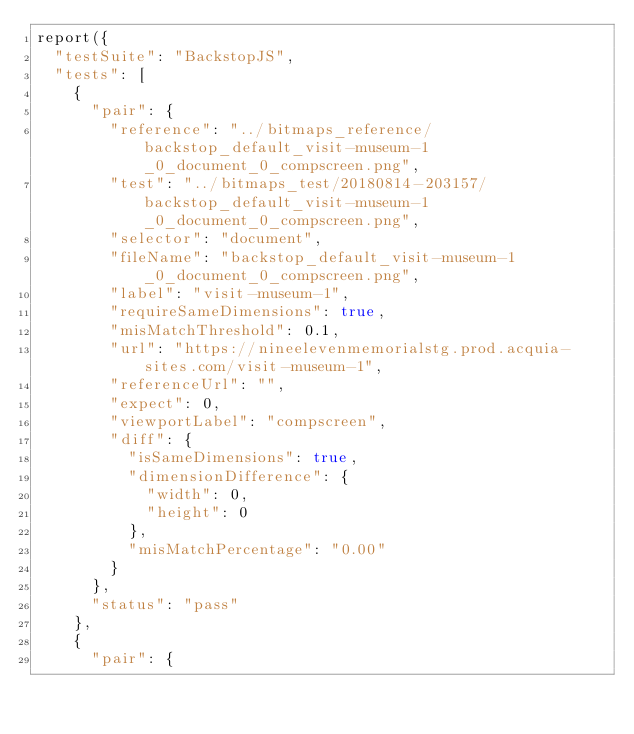Convert code to text. <code><loc_0><loc_0><loc_500><loc_500><_JavaScript_>report({
  "testSuite": "BackstopJS",
  "tests": [
    {
      "pair": {
        "reference": "../bitmaps_reference/backstop_default_visit-museum-1_0_document_0_compscreen.png",
        "test": "../bitmaps_test/20180814-203157/backstop_default_visit-museum-1_0_document_0_compscreen.png",
        "selector": "document",
        "fileName": "backstop_default_visit-museum-1_0_document_0_compscreen.png",
        "label": "visit-museum-1",
        "requireSameDimensions": true,
        "misMatchThreshold": 0.1,
        "url": "https://nineelevenmemorialstg.prod.acquia-sites.com/visit-museum-1",
        "referenceUrl": "",
        "expect": 0,
        "viewportLabel": "compscreen",
        "diff": {
          "isSameDimensions": true,
          "dimensionDifference": {
            "width": 0,
            "height": 0
          },
          "misMatchPercentage": "0.00"
        }
      },
      "status": "pass"
    },
    {
      "pair": {</code> 